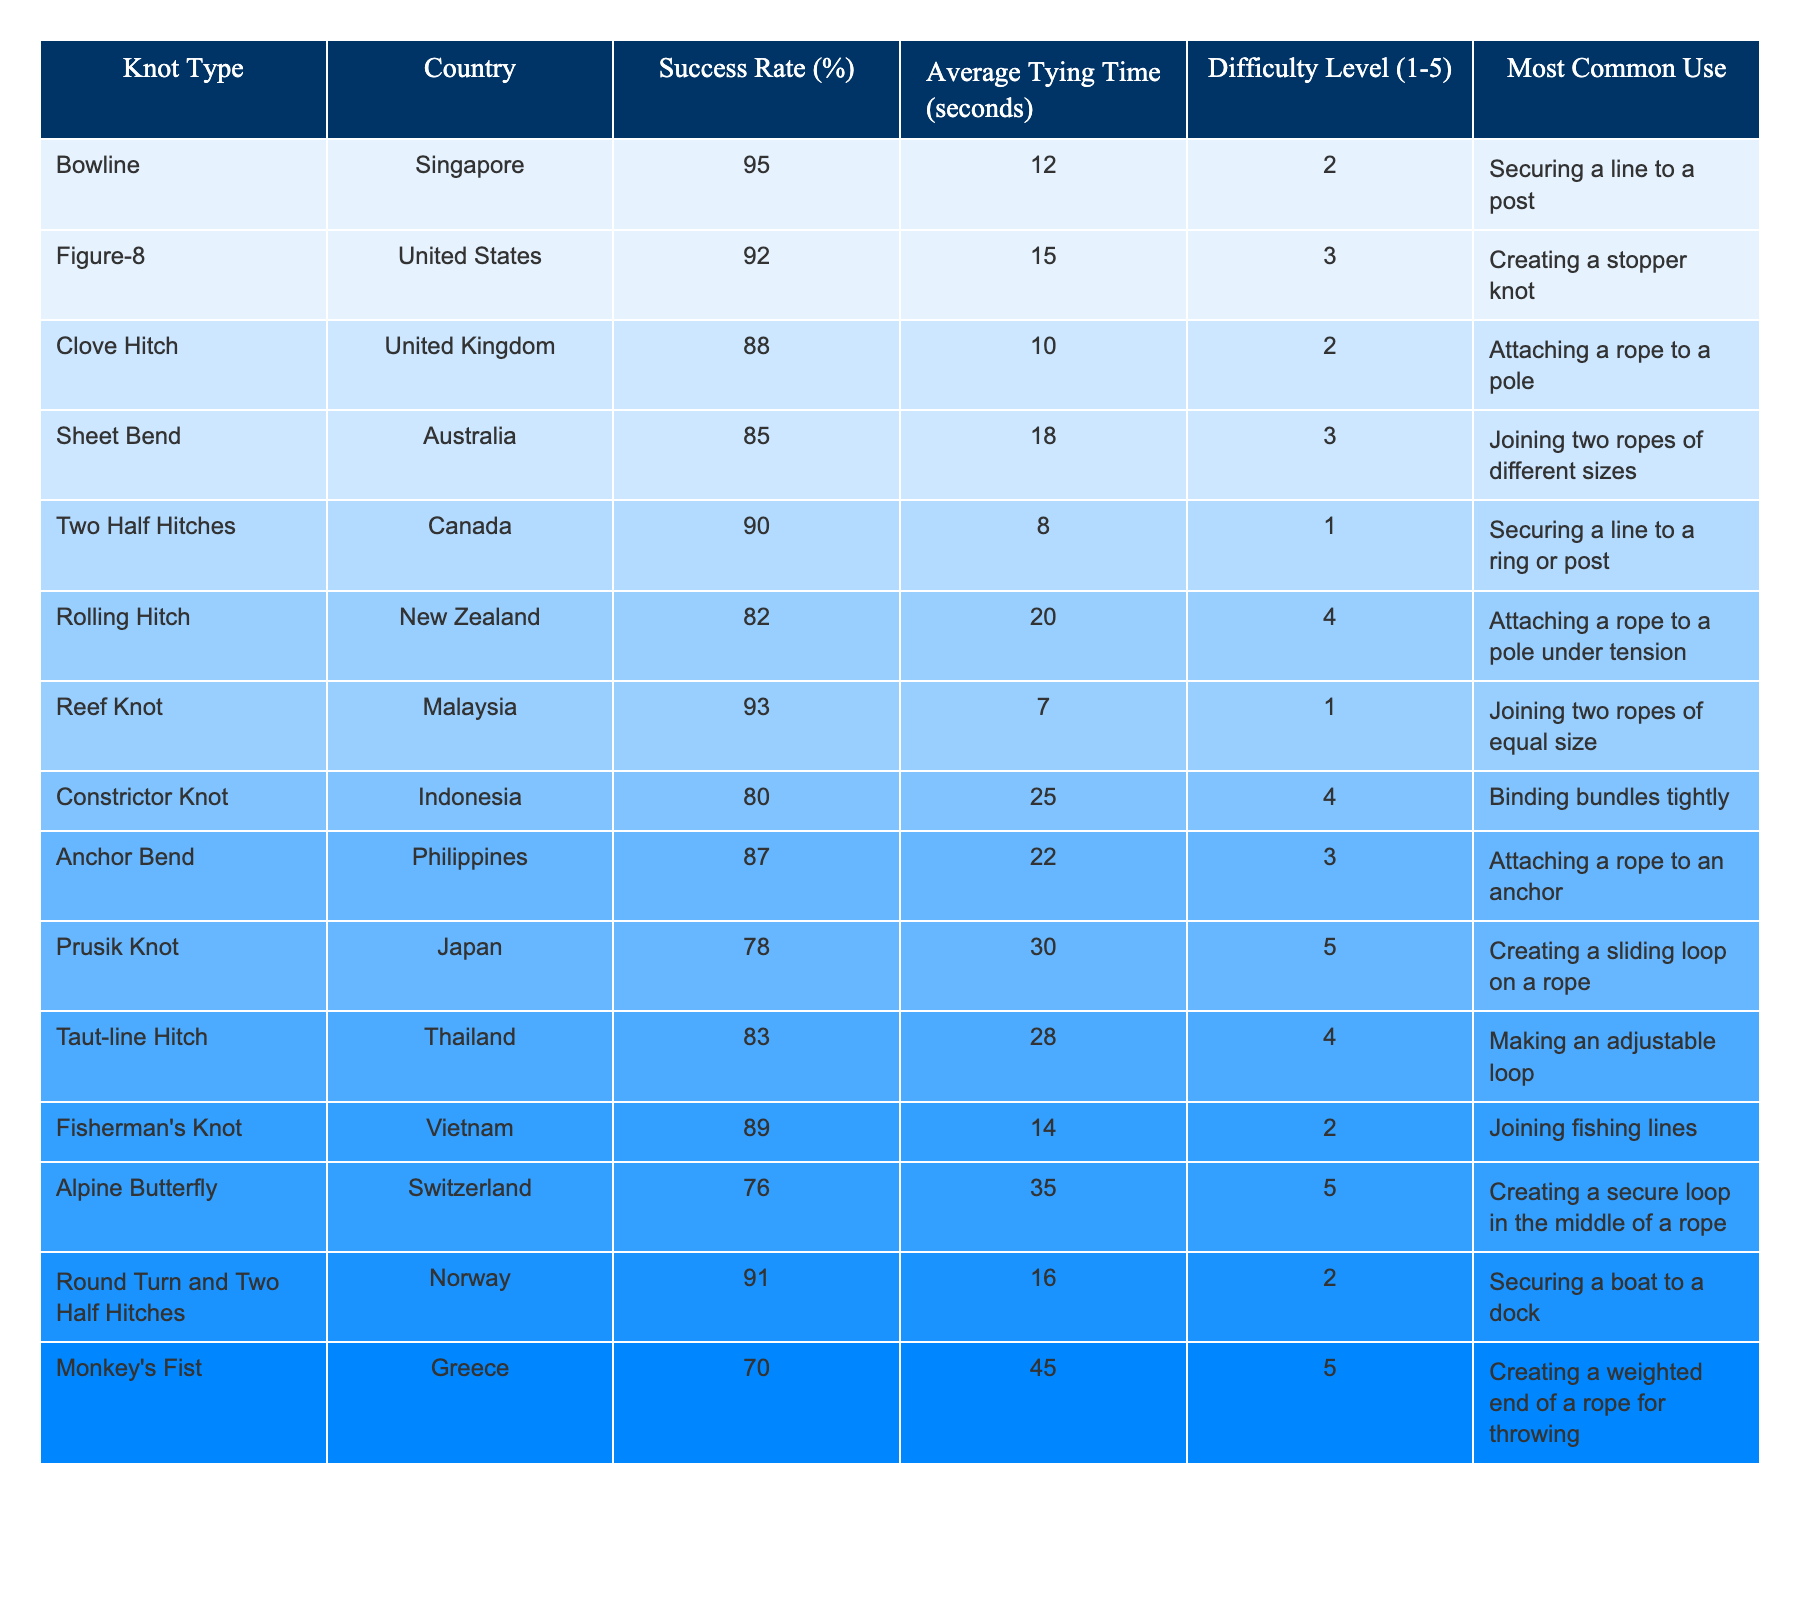What is the success rate of the Bowline knot? The table lists the Bowline knot under the Knot Type column, and its corresponding Success Rate is given in the Success Rate (%) column. It shows a success rate of 95%.
Answer: 95% Which knot has the longest average tying time? By examining the Average Tying Time (seconds) column, I can compare all the values. The Prusik Knot has the highest time listed at 30 seconds.
Answer: 30 seconds Is the Reef Knot easier than the Two Half Hitches? The difficulty for the Reef Knot is 1, while the difficulty for the Two Half Hitches is 1 as well. Since they have the same difficulty rating, they are equally easy.
Answer: Yes What is the average success rate of knots from Asia? The success rates of Asian knots listed are: Bowline (Singapore 95%), Sheet Bend (Australia 85%), Two Half Hitches (Canada 90%), and Prusik Knot (Japan 78%). Adding these: 95 + 85 + 90 + 78 = 348, then divide by 4 (the number of knots): 348 / 4 = 87.
Answer: 87% Which knot has the lowest success rate and what is its value? The success rates of all knots must be examined. The Constrictor Knot from Indonesia has the lowest success rate at 80%.
Answer: 80% How many knots have a success rate above 90%? By reviewing the Success Rate column, the knots above 90% are Bowline (95%), Figure-8 (92%), Reef Knot (93%), and Round Turn and Two Half Hitches (91%). This totals 4 knots.
Answer: 4 Do any knots have a difficulty level of 5? The table indicates that the Prusik Knot and the Alpine Butterfly both have a difficulty level of 5. Thus, there are knots with this level of difficulty.
Answer: Yes What is the difference in average tying time between the Monkey's Fist and the Clove Hitch? The average tying time for the Monkey's Fist is 45 seconds and the Clove Hitch is 10 seconds. Calculating the difference: 45 - 10 = 35 seconds.
Answer: 35 seconds Which knot is primarily used for securing a line to a post and what is its success rate? The Bowline is listed as securing a line to a post and has a success rate of 95%.
Answer: Bowline, 95% How many knots are designed for attaching a rope to a pole? In the table, the knots Clove Hitch and Rolling Hitch are designed for this purpose. Since there are 2 such knots, I find the answer.
Answer: 2 